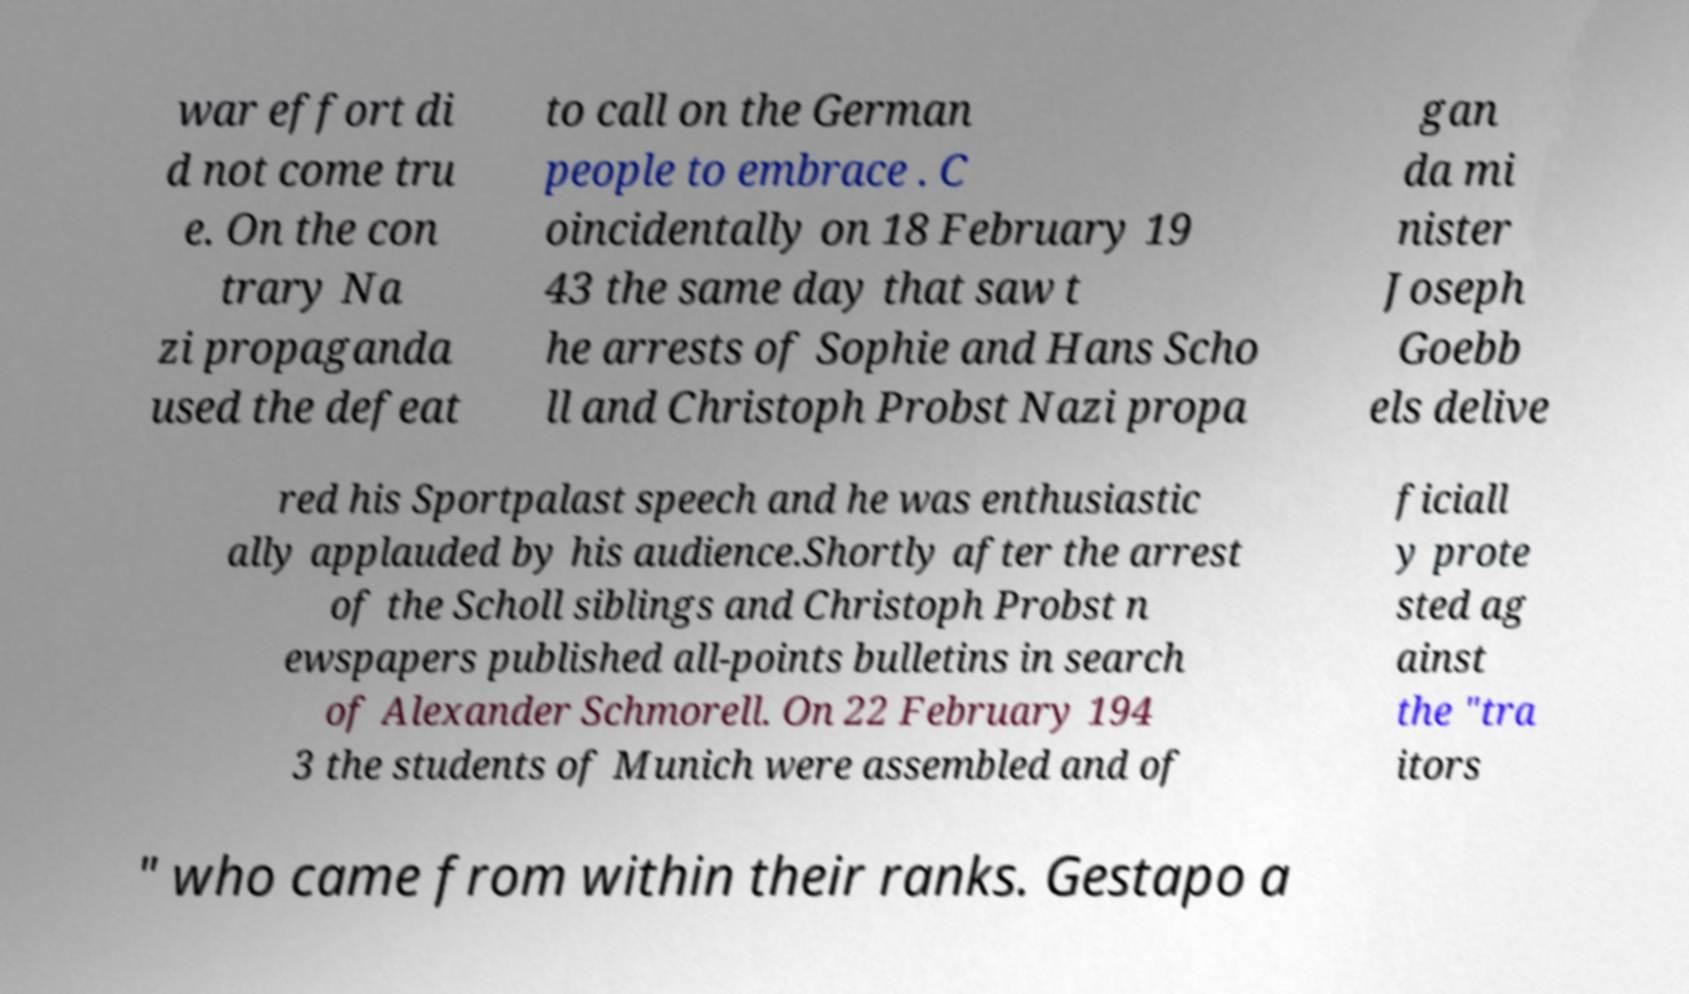For documentation purposes, I need the text within this image transcribed. Could you provide that? war effort di d not come tru e. On the con trary Na zi propaganda used the defeat to call on the German people to embrace . C oincidentally on 18 February 19 43 the same day that saw t he arrests of Sophie and Hans Scho ll and Christoph Probst Nazi propa gan da mi nister Joseph Goebb els delive red his Sportpalast speech and he was enthusiastic ally applauded by his audience.Shortly after the arrest of the Scholl siblings and Christoph Probst n ewspapers published all-points bulletins in search of Alexander Schmorell. On 22 February 194 3 the students of Munich were assembled and of ficiall y prote sted ag ainst the "tra itors " who came from within their ranks. Gestapo a 